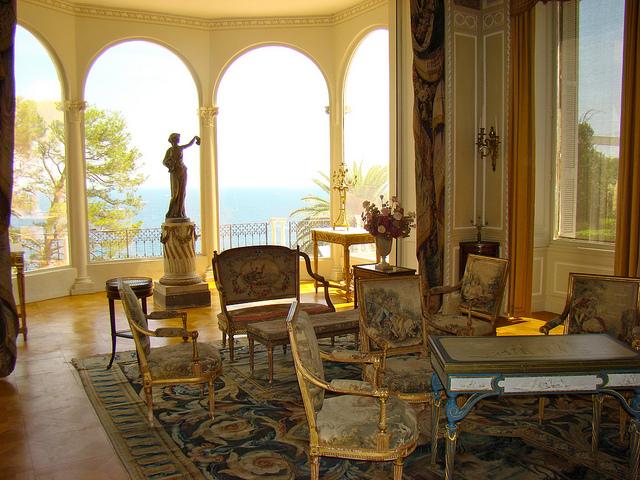What is in the landscape outside of the window?
Keep it brief. Ocean. Are there trees in the picture?
Be succinct. Yes. How many chairs are in the picture?
Concise answer only. 6. 